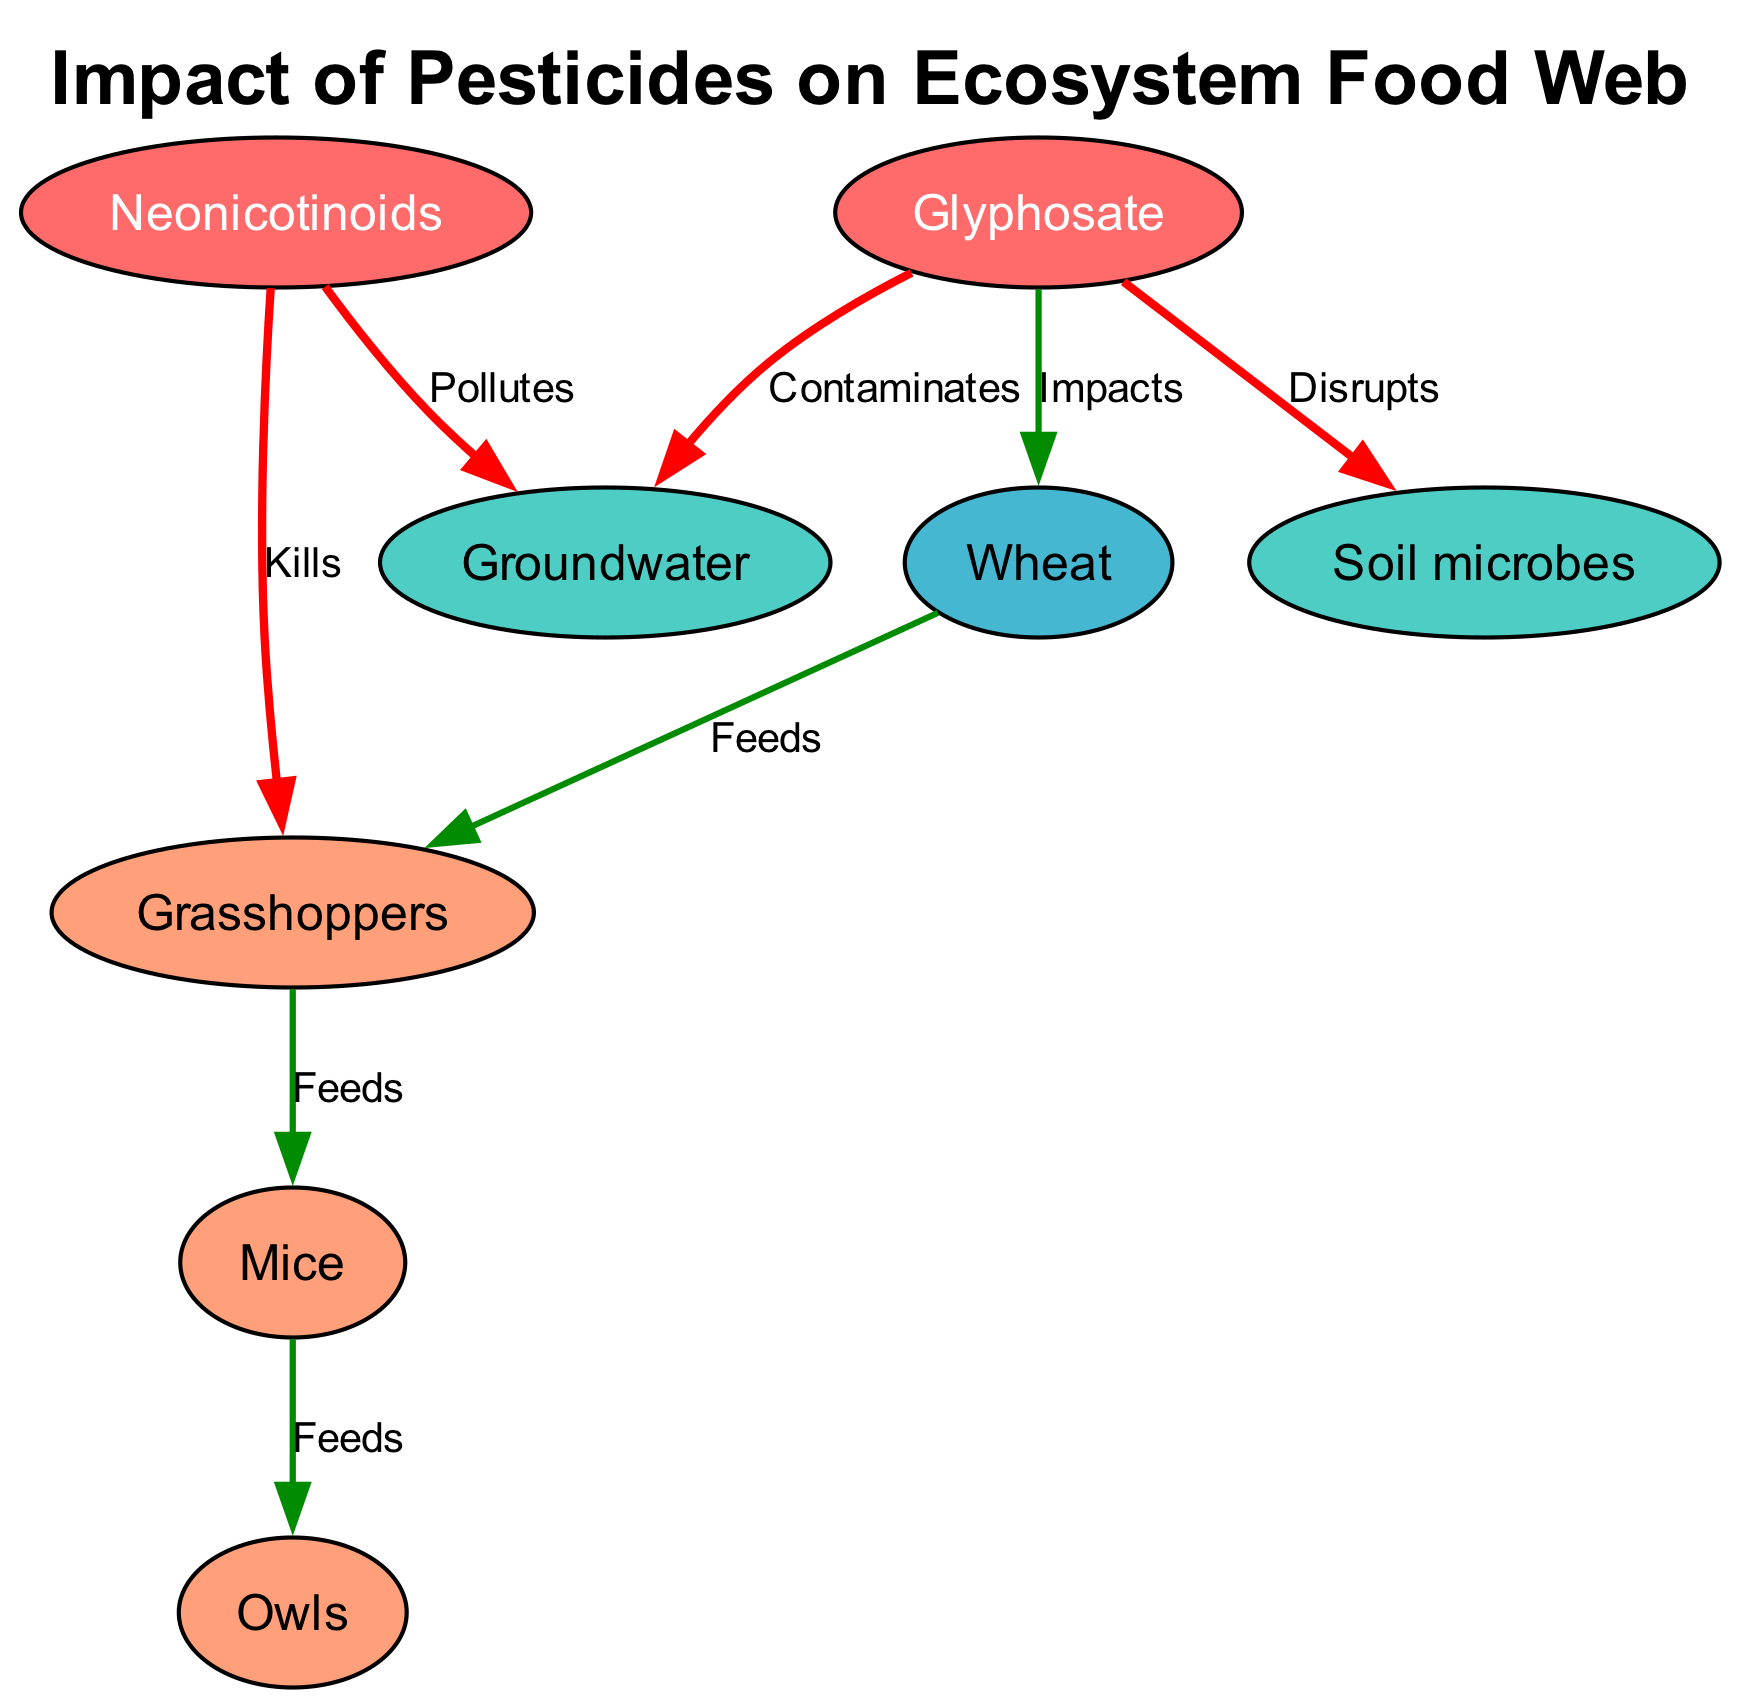What are the two types of pesticides shown in the diagram? The diagram displays two nodes labeled as "Glyphosate" and "Neonicotinoids", which are specifically colored to indicate their role as pesticides impacting the ecosystem.
Answer: Glyphosate, Neonicotinoids How many nodes are in the diagram? By counting the individual nodes listed in the data, which include Wheat, Grasshoppers, Mice, Owls, Glyphosate, Neonicotinoids, Soil microbes, and Groundwater, there are a total of 8 nodes.
Answer: 8 Which organism feeds on Grasshoppers? The diagram indicates that Mice is the node that receives a "Feeds" arrow from Grasshoppers, showing that Mice consume them.
Answer: Mice What is the impact of Glyphosate on Wheat? The connection labeled "Impacts" from Glyphosate to Wheat indicates a negative or harmful effect that Glyphosate has on Wheat, although further details about the nature of the impact are not provided.
Answer: Impacts Which ties connect Neonicotinoids to the environment? Neonicotinoids are connected to Groundwater with a “Pollutes” label and to Grasshoppers with a “Kills” label, indicating direct environmental consequences from its usage and effects on the food web.
Answer: Groundwater, Grasshoppers How many edges represent feeding relationships? The diagram illustrates four edges labeled "Feeds", which connect the nodes Wheat to Grasshoppers, Grasshoppers to Mice, and Mice to Owls, demonstrating the natural feeding pathways.
Answer: 4 What nodes are affected by the impact of pesticides? Both Glyphosate and Neonicotinoids impact Wheat, Soil microbes, and Groundwater directly, indicating different pathways by which pesticides alter the ecosystem.
Answer: Wheat, Soil microbes, Groundwater What color represents the pesticides in the diagram? In the diagram, the pesticides Glyphosate and Neonicotinoids are represented in a red hue (specifically, "#FF6B6B") which denotes their harmful nature within this ecosystem context.
Answer: Red 